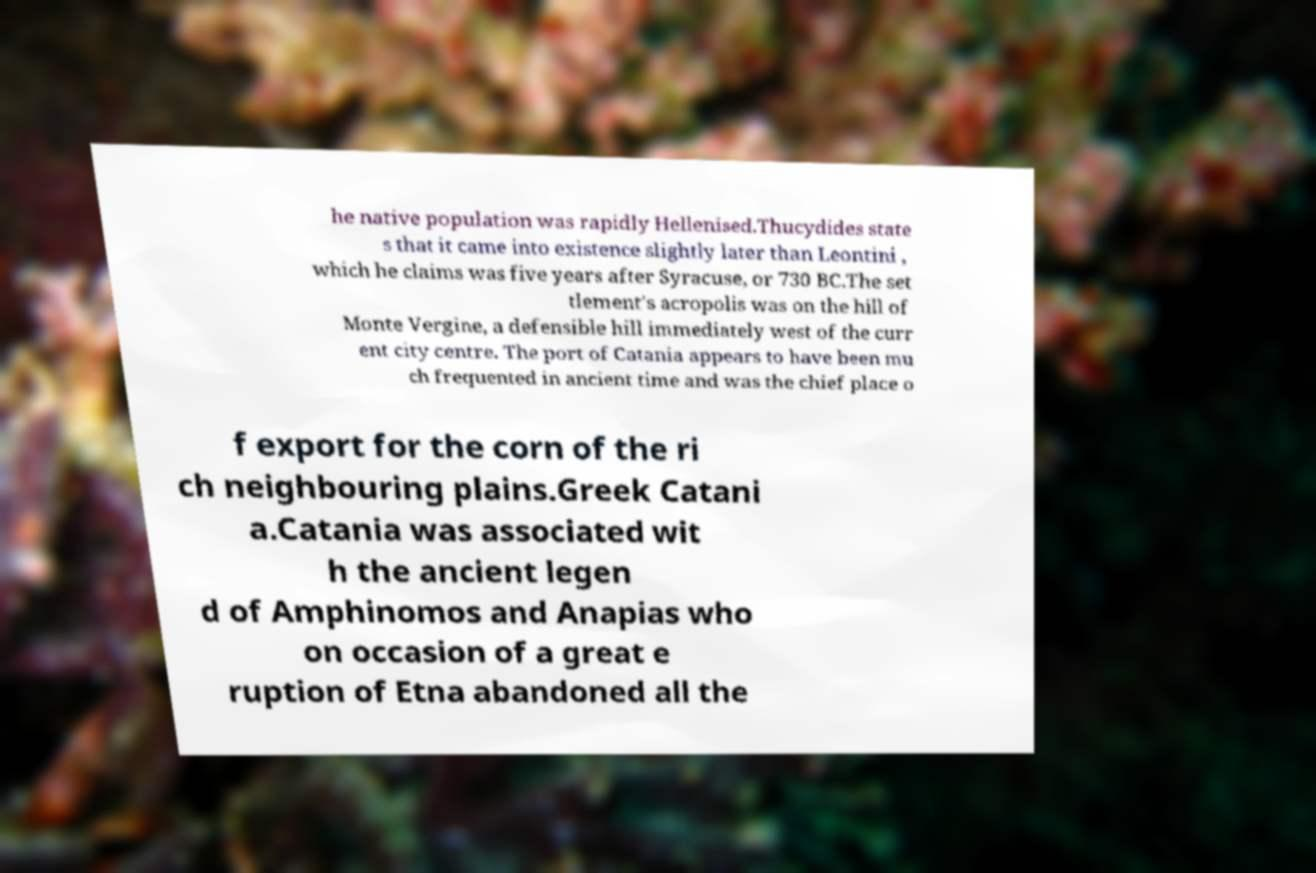For documentation purposes, I need the text within this image transcribed. Could you provide that? he native population was rapidly Hellenised.Thucydides state s that it came into existence slightly later than Leontini , which he claims was five years after Syracuse, or 730 BC.The set tlement's acropolis was on the hill of Monte Vergine, a defensible hill immediately west of the curr ent city centre. The port of Catania appears to have been mu ch frequented in ancient time and was the chief place o f export for the corn of the ri ch neighbouring plains.Greek Catani a.Catania was associated wit h the ancient legen d of Amphinomos and Anapias who on occasion of a great e ruption of Etna abandoned all the 